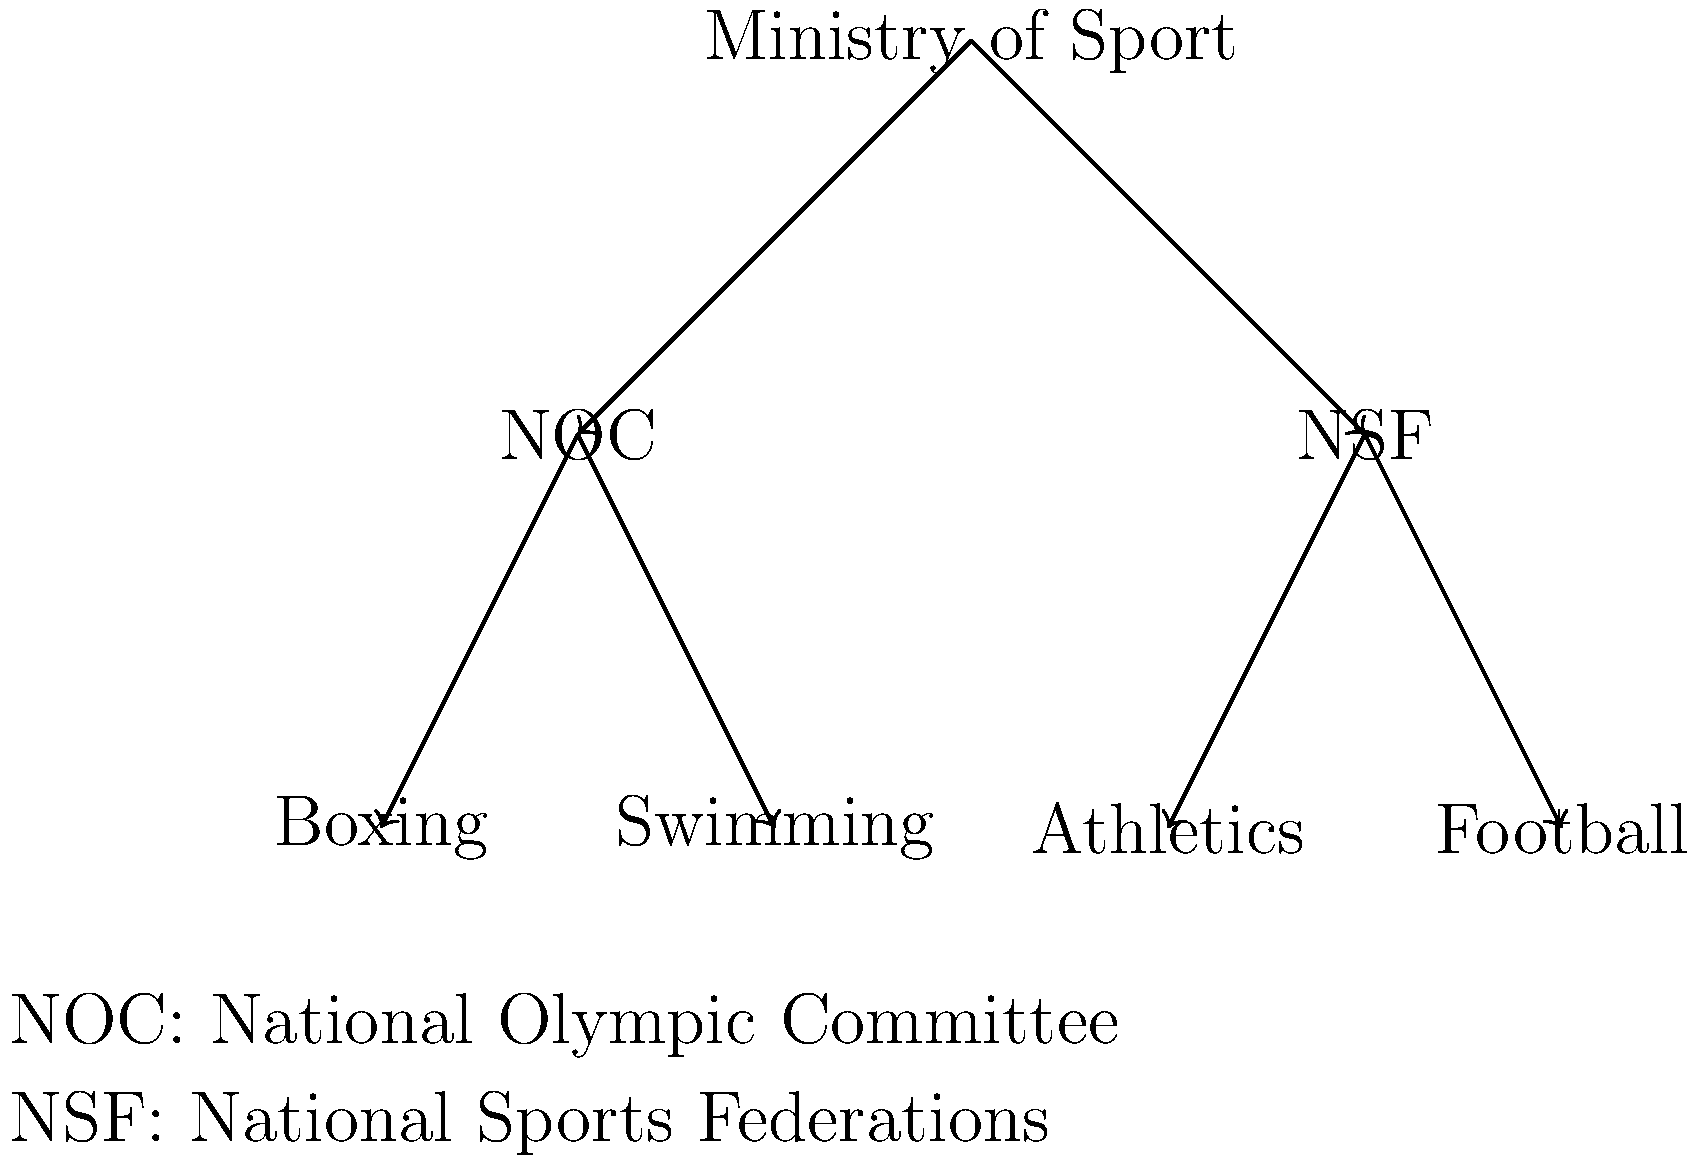In the hierarchical structure of sports organizations in Suriname, how many levels are present, and what is the relationship between the National Olympic Committee (NOC) and individual sports federations like Boxing and Swimming? To answer this question, let's analyze the hierarchical structure shown in the diagram:

1. The top level of the hierarchy is the Ministry of Sport, which oversees all sports-related activities in Suriname.

2. The second level consists of two main branches:
   a) The National Olympic Committee (NOC)
   b) The National Sports Federations (NSF)

3. The third level shows individual sports federations, such as Boxing, Swimming, Athletics, and Football.

4. Counting these levels, we can see that there are 3 distinct levels in the hierarchical structure.

5. Regarding the relationship between the NOC and individual sports federations:
   - The NOC is directly connected to Boxing and Swimming in the diagram.
   - This indicates that the NOC oversees and coordinates Olympic sports, including Boxing and Swimming.
   - The NOC likely provides support, resources, and guidance to these federations for Olympic-related matters.

6. It's worth noting that not all sports federations are under the NOC. Some, like Athletics and Football, are shown under the NSF branch, suggesting they may have different governing structures or relationships within the overall sports organization of Suriname.
Answer: 3 levels; NOC directly oversees Olympic sports federations 